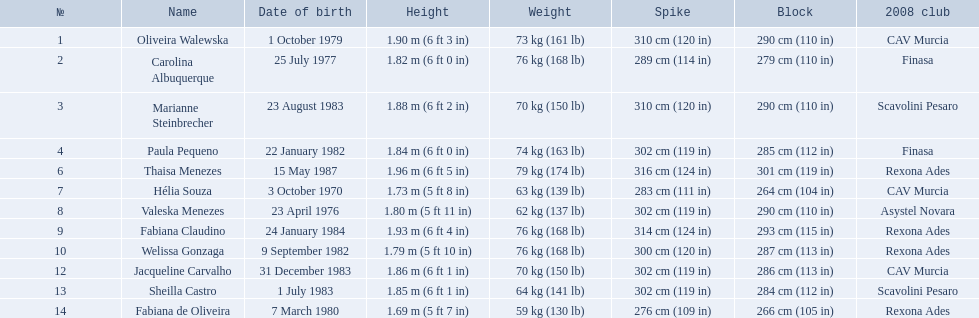Can you provide the full names of the contestants? Oliveira Walewska, Carolina Albuquerque, Marianne Steinbrecher, Paula Pequeno, Thaisa Menezes, Hélia Souza, Valeska Menezes, Fabiana Claudino, Welissa Gonzaga, Jacqueline Carvalho, Sheilla Castro, Fabiana de Oliveira. What are the various weight divisions of the participants? 73 kg (161 lb), 76 kg (168 lb), 70 kg (150 lb), 74 kg (163 lb), 79 kg (174 lb), 63 kg (139 lb), 62 kg (137 lb), 76 kg (168 lb), 76 kg (168 lb), 70 kg (150 lb), 64 kg (141 lb), 59 kg (130 lb). Among sheilla castro, fabiana de oliveira, and helia souza, who weighs the most? Sheilla Castro. What are the players' heights? 1.90 m (6 ft 3 in), 1.82 m (6 ft 0 in), 1.88 m (6 ft 2 in), 1.84 m (6 ft 0 in), 1.96 m (6 ft 5 in), 1.73 m (5 ft 8 in), 1.80 m (5 ft 11 in), 1.93 m (6 ft 4 in), 1.79 m (5 ft 10 in), 1.86 m (6 ft 1 in), 1.85 m (6 ft 1 in), 1.69 m (5 ft 7 in). Which height is the lowest? 1.69 m (5 ft 7 in). Who stands at 5'7? Fabiana de Oliveira. 